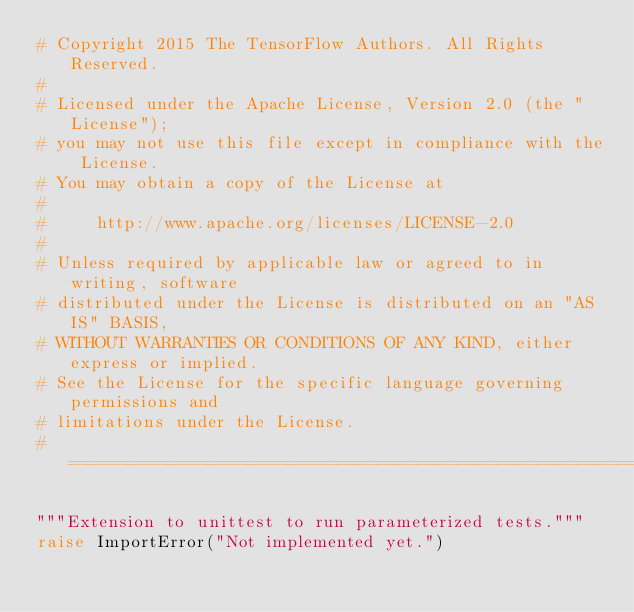<code> <loc_0><loc_0><loc_500><loc_500><_Python_># Copyright 2015 The TensorFlow Authors. All Rights Reserved.
#
# Licensed under the Apache License, Version 2.0 (the "License");
# you may not use this file except in compliance with the License.
# You may obtain a copy of the License at
#
#     http://www.apache.org/licenses/LICENSE-2.0
#
# Unless required by applicable law or agreed to in writing, software
# distributed under the License is distributed on an "AS IS" BASIS,
# WITHOUT WARRANTIES OR CONDITIONS OF ANY KIND, either express or implied.
# See the License for the specific language governing permissions and
# limitations under the License.
# ==============================================================================

"""Extension to unittest to run parameterized tests."""
raise ImportError("Not implemented yet.")
</code> 